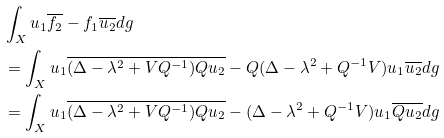<formula> <loc_0><loc_0><loc_500><loc_500>& \int _ { X } u _ { 1 } \overline { f _ { 2 } } - f _ { 1 } \overline { u _ { 2 } } d g \\ & = \int _ { X } u _ { 1 } \overline { ( \Delta - \lambda ^ { 2 } + V Q ^ { - 1 } ) Q u _ { 2 } } - Q ( \Delta - \lambda ^ { 2 } + Q ^ { - 1 } V ) u _ { 1 } \overline { u _ { 2 } } d g \\ & = \int _ { X } u _ { 1 } \overline { ( \Delta - \lambda ^ { 2 } + V Q ^ { - 1 } ) Q u _ { 2 } } - ( \Delta - \lambda ^ { 2 } + Q ^ { - 1 } V ) u _ { 1 } \overline { Q u _ { 2 } } d g</formula> 